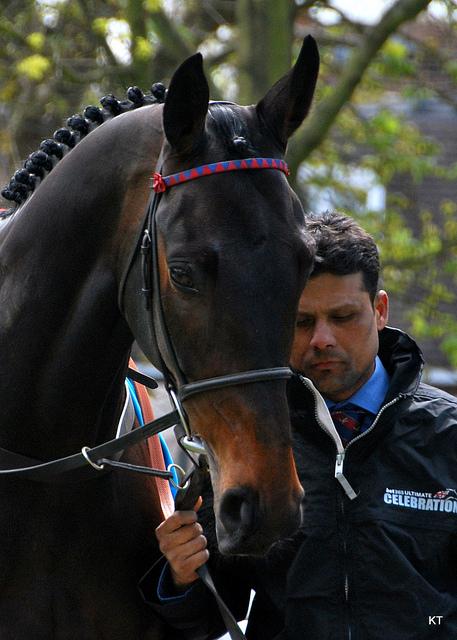What color is the man's head?
Keep it brief. Brown. Does the horse have a little white on his face?
Be succinct. No. Does the horse have a muzzle?
Concise answer only. No. What color is the horse?
Answer briefly. Black. 